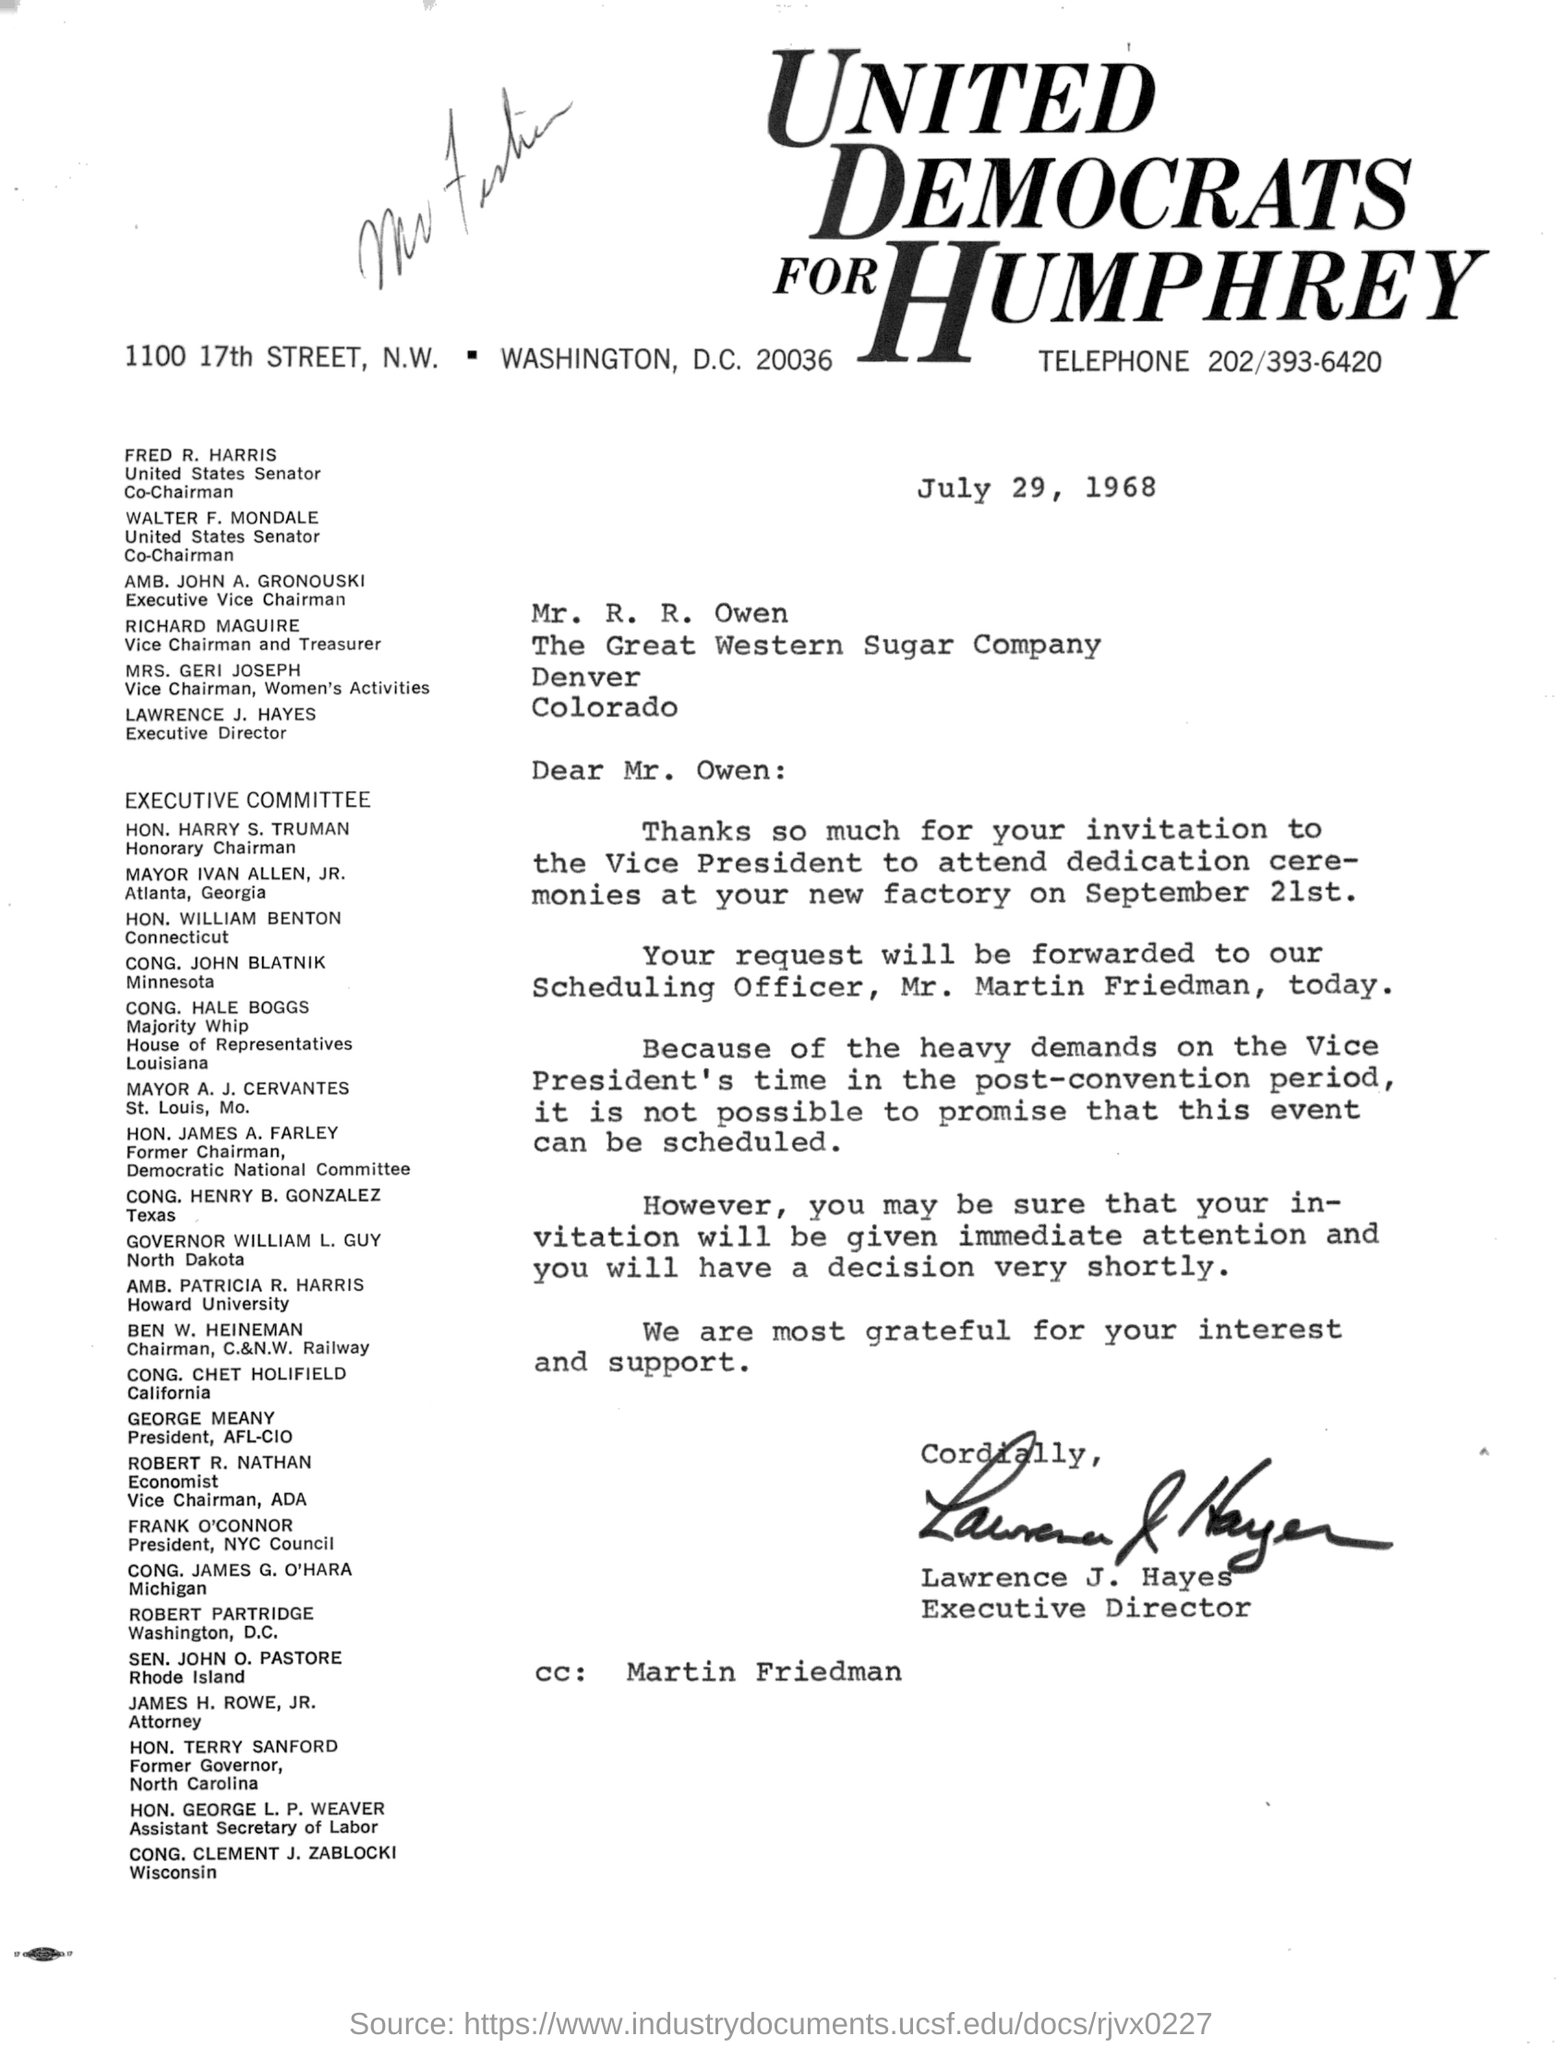Give some essential details in this illustration. Martin Friedman is included in CC. The date mentioned in the document is July 29, 1968. 